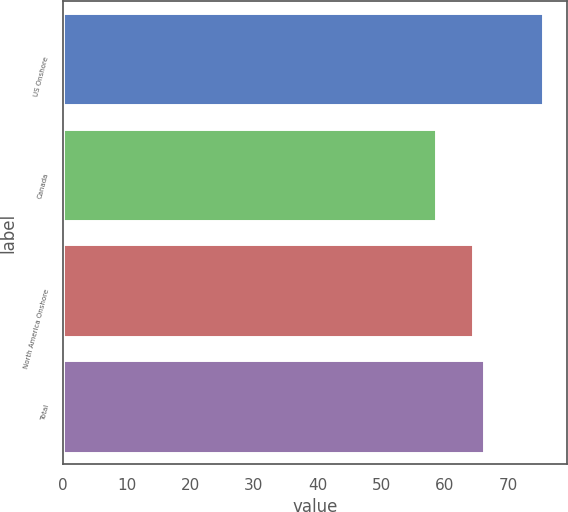Convert chart. <chart><loc_0><loc_0><loc_500><loc_500><bar_chart><fcel>US Onshore<fcel>Canada<fcel>North America Onshore<fcel>Total<nl><fcel>75.53<fcel>58.6<fcel>64.51<fcel>66.2<nl></chart> 